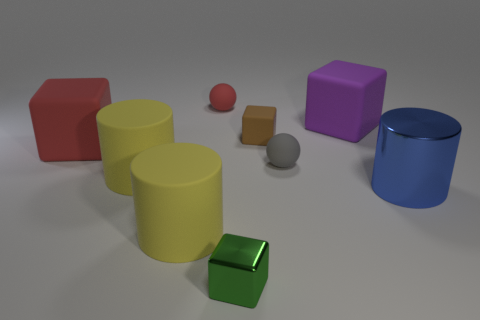Does the matte thing that is on the right side of the tiny gray object have the same size as the cylinder that is behind the metal cylinder?
Offer a very short reply. Yes. Are there fewer big blocks than small green shiny things?
Make the answer very short. No. There is a gray rubber thing; how many gray spheres are in front of it?
Your answer should be very brief. 0. What is the small brown thing made of?
Offer a very short reply. Rubber. Is the metal cylinder the same color as the small matte cube?
Ensure brevity in your answer.  No. Are there fewer large yellow cylinders that are on the right side of the tiny gray thing than large purple rubber objects?
Provide a succinct answer. Yes. What is the color of the big rubber object on the right side of the tiny brown cube?
Provide a succinct answer. Purple. What shape is the small green metal thing?
Your answer should be very brief. Cube. There is a rubber ball that is right of the metallic thing in front of the big blue object; are there any big red cubes that are in front of it?
Make the answer very short. No. There is a sphere that is behind the large rubber object that is on the right side of the tiny matte ball behind the gray ball; what color is it?
Your response must be concise. Red. 